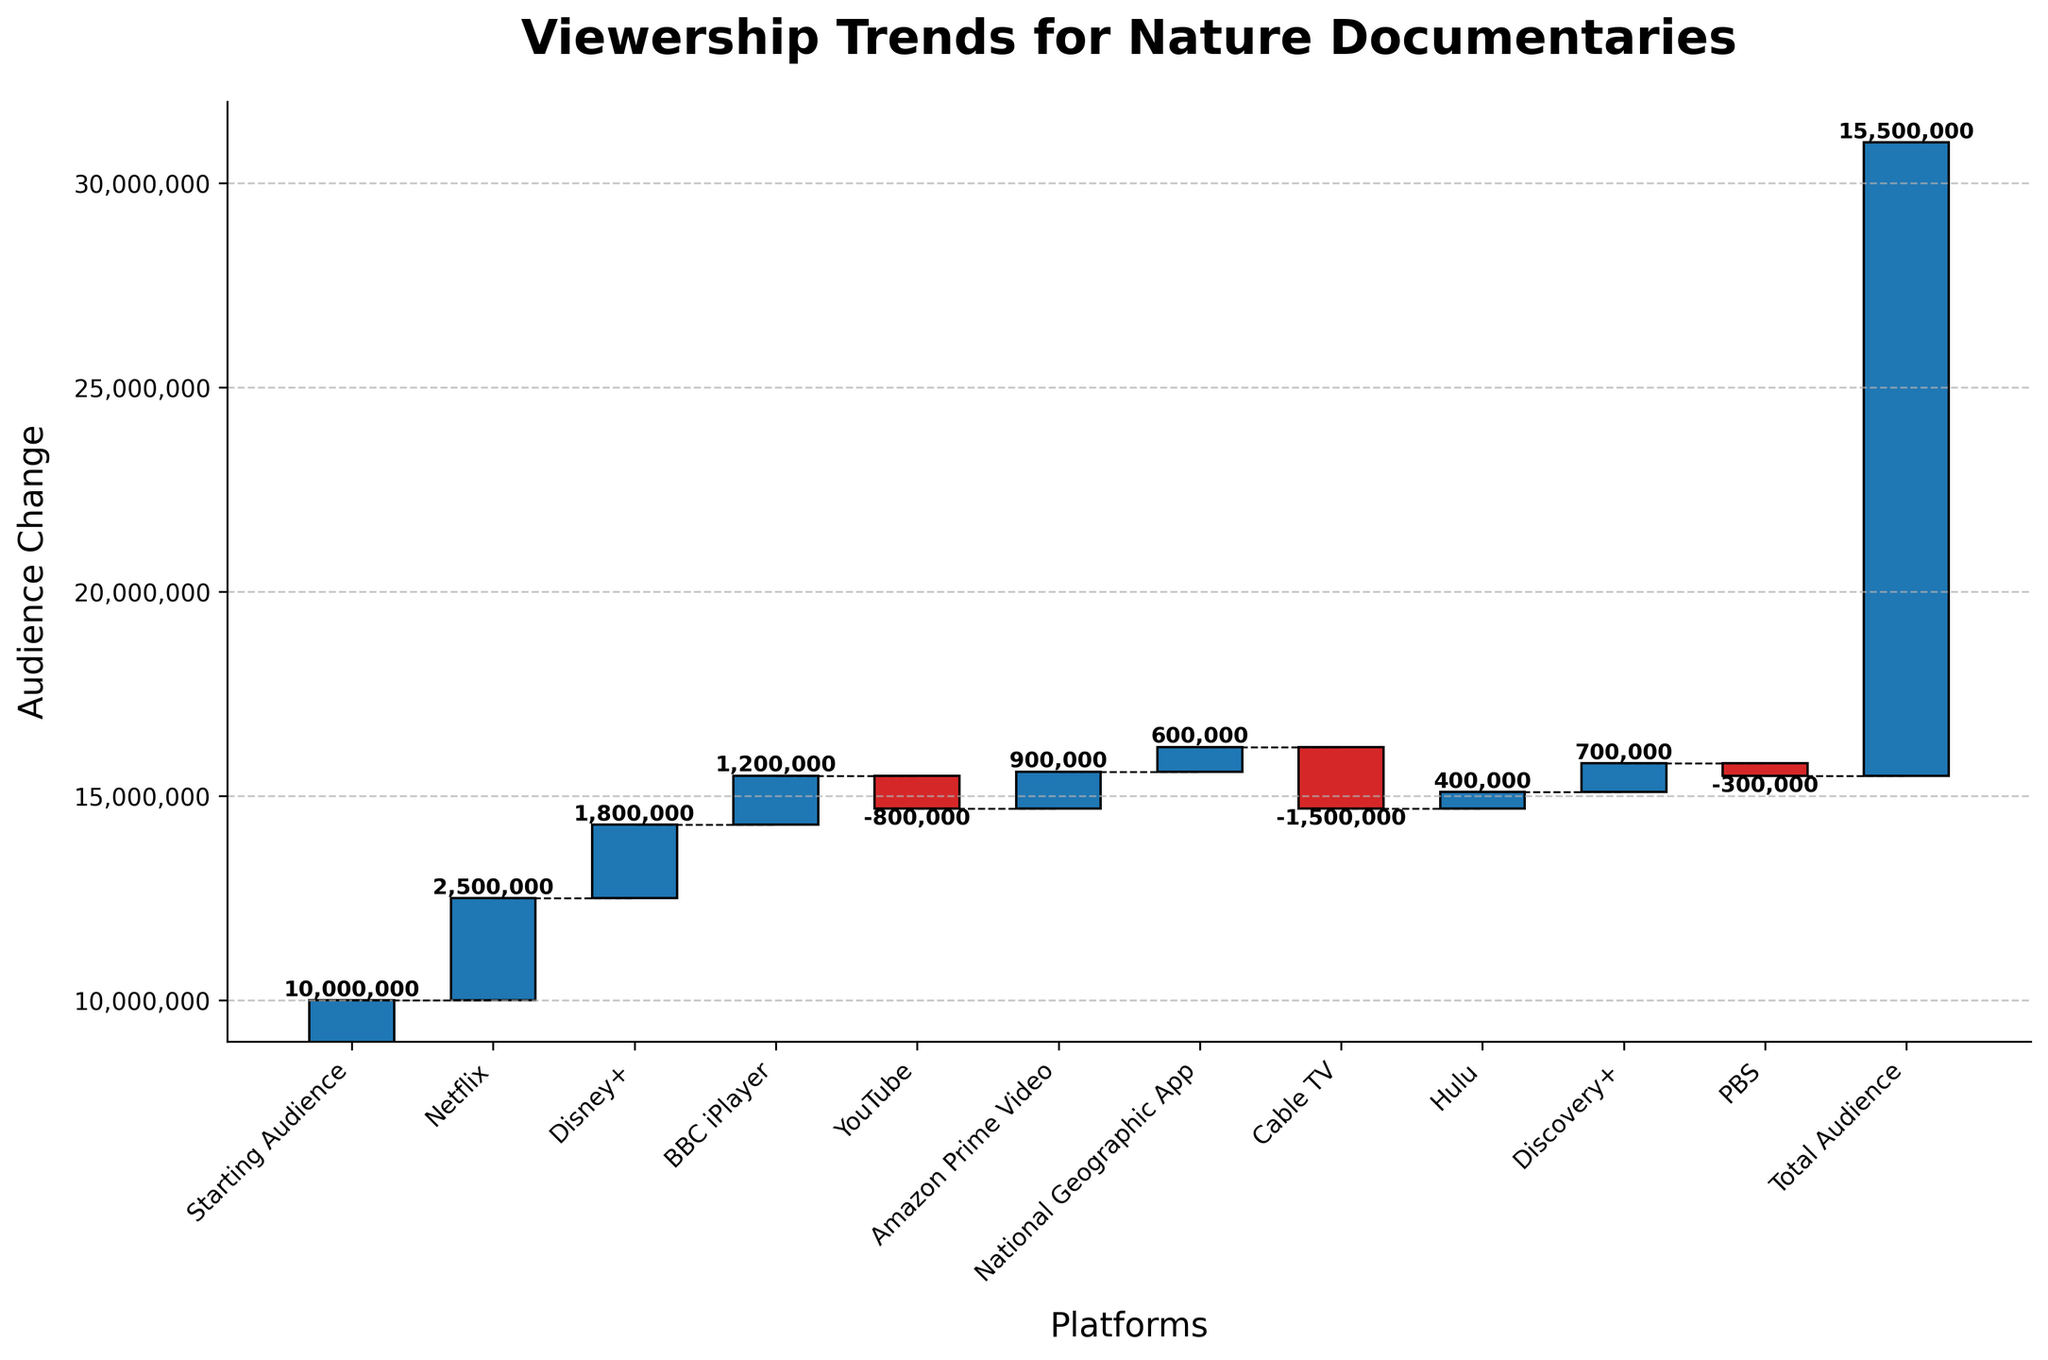what is the title of the chart? The title of the chart is displayed at the top of the figure. The title provides a summary of what the chart represents.
Answer: Viewership Trends for Nature Documentaries How much is the starting audience? The starting audience is listed as the first category in the chart along with its corresponding value.
Answer: 10,000,000 Which platform has the largest gain in audience share? By comparing the positive values, the platform with the highest value indicates the largest gain.
Answer: Netflix What are the total gains from all platforms combined? To find total gains, sum the positive audience values from the platforms (Netflix, Disney+, BBC iPlayer, Amazon Prime Video, National Geographic App, Hulu, Discovery+). Calculation: 2,500,000 + 1,800,000 + 1,200,000 + 900,000 + 600,000 + 400,000 + 700,000 = 8,100,000.
Answer: 8,100,000 Which platform has the largest loss in audience share? By comparing the negative values, the platform with the highest negative value indicates the largest loss.
Answer: Cable TV What is the net change in audience after including all the platforms contributing positively and negatively? Sum all the values of gains and losses from the platforms (including negative gains). Calculation: 2,500,000 + 1,800,000 + 1,200,000 - 800,000 + 900,000 + 600,000 - 1,500,000 + 400,000 + 700,000 - 300,000 = 5,500,000.
Answer: 5,500,000 How does the audience change from Cable TV compare with that from YouTube? By comparing the absolute values of the losses for both platforms. Cable TV: -1,500,000, YouTube: -800,000.
Answer: Cable TV has a larger loss What is the final audience size depicted in the chart? The final audience size is given under the 'Total Audience' category.
Answer: 15,500,000 What is the total loss in audience from all platforms combined? Sum the negative values from the platforms (YouTube, Cable TV, PBS). Calculation: -800,000 - 1,500,000 - 300,000 = -2,600,000.
Answer: 2,600,000 How does the gain in audience share from Amazon Prime Video compare to that from Hulu? Compare the values for Amazon Prime Video and Hulu. Amazon Prime Video: 900,000, Hulu: 400,000.
Answer: Amazon Prime Video has a larger gain 